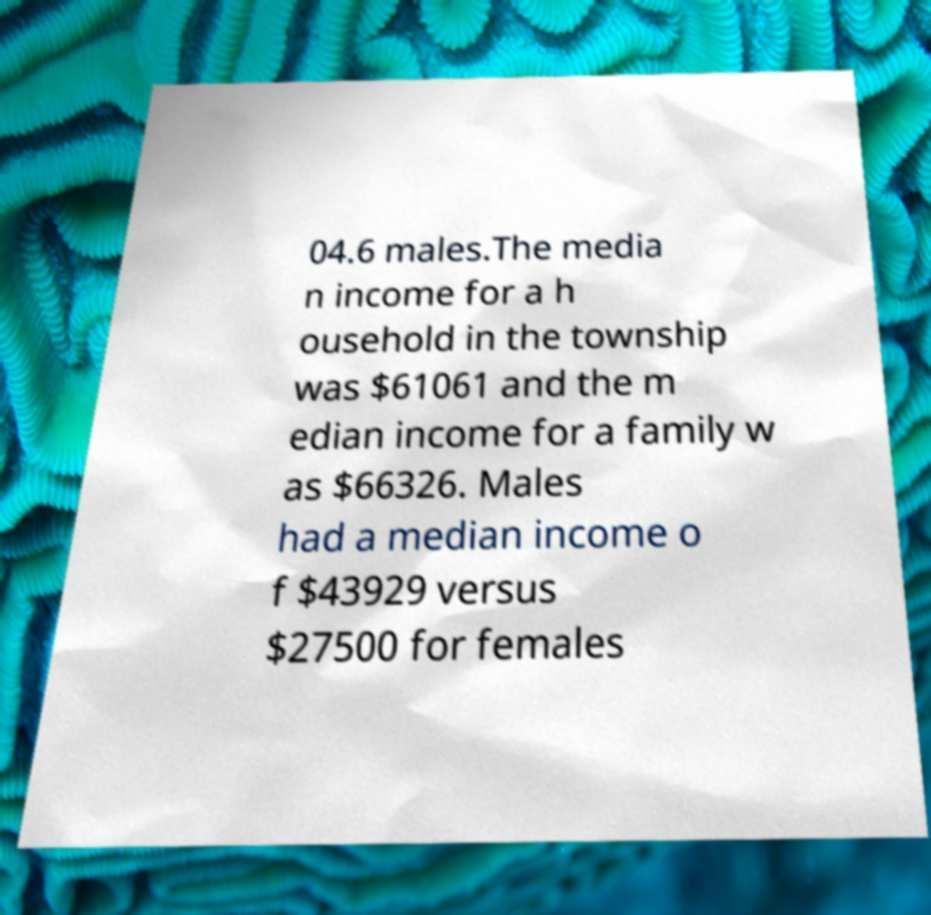Please read and relay the text visible in this image. What does it say? 04.6 males.The media n income for a h ousehold in the township was $61061 and the m edian income for a family w as $66326. Males had a median income o f $43929 versus $27500 for females 